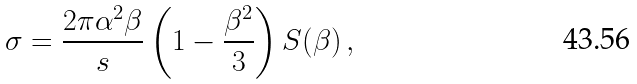Convert formula to latex. <formula><loc_0><loc_0><loc_500><loc_500>\sigma = \frac { 2 \pi \alpha ^ { 2 } \beta } { s } \left ( 1 - \frac { \beta ^ { 2 } } { 3 } \right ) S ( \beta ) \, ,</formula> 